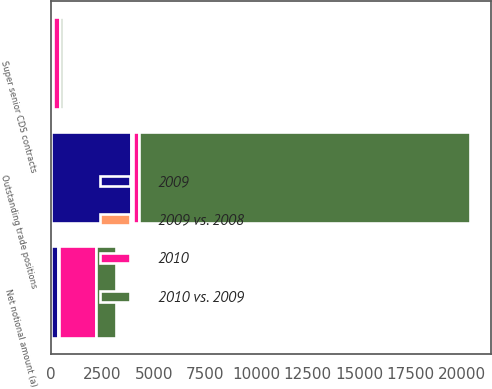Convert chart. <chart><loc_0><loc_0><loc_500><loc_500><stacked_bar_chart><ecel><fcel>Net notional amount (a)<fcel>Super senior CDS contracts<fcel>Outstanding trade positions<nl><fcel>2009<fcel>353<fcel>60<fcel>3900<nl><fcel>2010 vs. 2009<fcel>941<fcel>184<fcel>16100<nl><fcel>2010<fcel>1800<fcel>302<fcel>302<nl><fcel>2009 vs. 2008<fcel>62<fcel>67<fcel>76<nl></chart> 